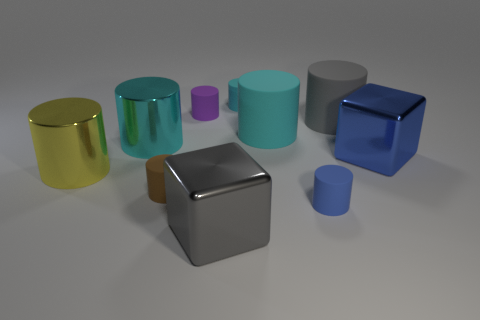Subtract all brown cylinders. How many cylinders are left? 7 Subtract all gray blocks. How many blocks are left? 1 Subtract 7 cylinders. How many cylinders are left? 1 Subtract all cubes. How many objects are left? 8 Add 9 small blue matte spheres. How many small blue matte spheres exist? 9 Subtract 0 gray spheres. How many objects are left? 10 Subtract all yellow cylinders. Subtract all cyan cubes. How many cylinders are left? 7 Subtract all blue spheres. How many blue cubes are left? 1 Subtract all small blue matte cylinders. Subtract all yellow metallic objects. How many objects are left? 8 Add 5 blue objects. How many blue objects are left? 7 